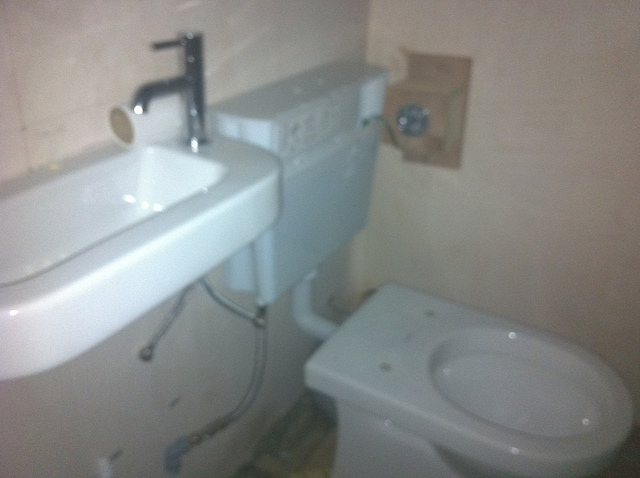What color are the tiles in this bathroom? The tiles appear to be a light beige or cream color, matching the overall neutral tone of the bathroom. What kind of tap is on the sink? The sink is fitted with a single, modern-looking mixer tap with a chrome finish. 